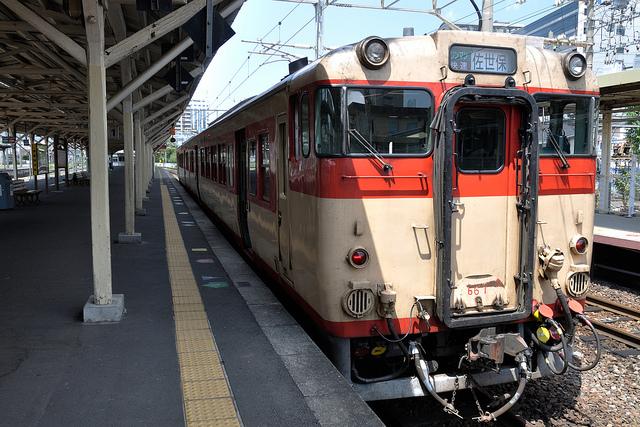What objects have a bit of tan color to theme?
Be succinct. Train. What country is this train in?
Quick response, please. Japan. Where is the train pulled up to?
Be succinct. Station. 